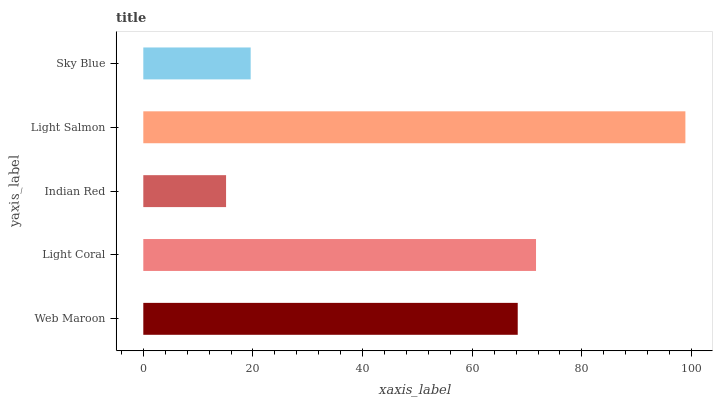Is Indian Red the minimum?
Answer yes or no. Yes. Is Light Salmon the maximum?
Answer yes or no. Yes. Is Light Coral the minimum?
Answer yes or no. No. Is Light Coral the maximum?
Answer yes or no. No. Is Light Coral greater than Web Maroon?
Answer yes or no. Yes. Is Web Maroon less than Light Coral?
Answer yes or no. Yes. Is Web Maroon greater than Light Coral?
Answer yes or no. No. Is Light Coral less than Web Maroon?
Answer yes or no. No. Is Web Maroon the high median?
Answer yes or no. Yes. Is Web Maroon the low median?
Answer yes or no. Yes. Is Light Salmon the high median?
Answer yes or no. No. Is Indian Red the low median?
Answer yes or no. No. 